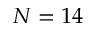<formula> <loc_0><loc_0><loc_500><loc_500>N = 1 4</formula> 